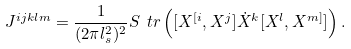<formula> <loc_0><loc_0><loc_500><loc_500>J ^ { i j k l m } = \frac { 1 } { ( 2 \pi l _ { s } ^ { 2 } ) ^ { 2 } } S \ t r \left ( [ X ^ { [ i } , X ^ { j } ] \dot { X } ^ { k } [ X ^ { l } , X ^ { m ] } ] \right ) .</formula> 